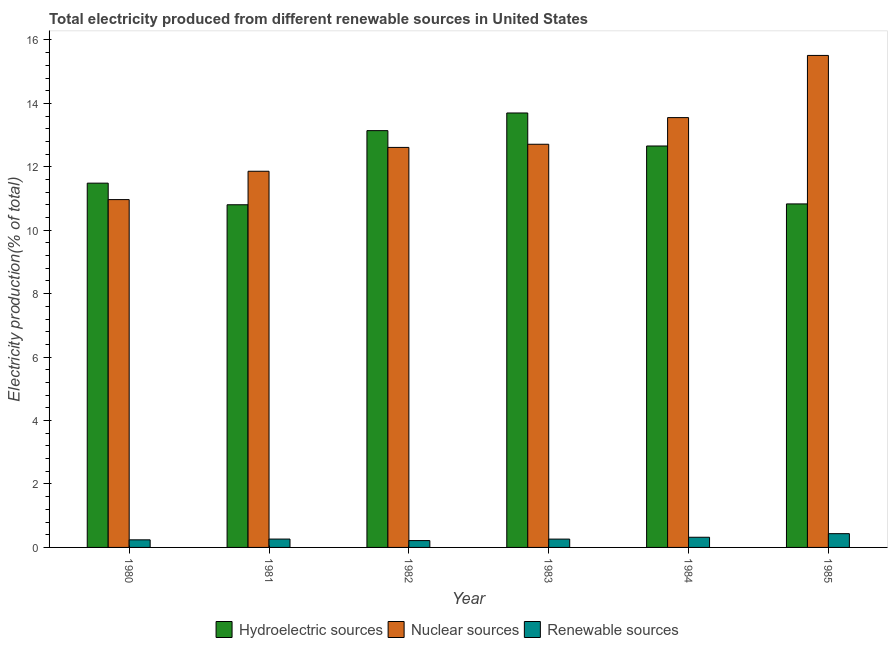How many groups of bars are there?
Ensure brevity in your answer.  6. Are the number of bars on each tick of the X-axis equal?
Your answer should be compact. Yes. How many bars are there on the 5th tick from the left?
Keep it short and to the point. 3. How many bars are there on the 4th tick from the right?
Provide a short and direct response. 3. What is the label of the 1st group of bars from the left?
Keep it short and to the point. 1980. What is the percentage of electricity produced by nuclear sources in 1980?
Make the answer very short. 10.97. Across all years, what is the maximum percentage of electricity produced by hydroelectric sources?
Offer a terse response. 13.7. Across all years, what is the minimum percentage of electricity produced by renewable sources?
Provide a short and direct response. 0.22. In which year was the percentage of electricity produced by hydroelectric sources maximum?
Give a very brief answer. 1983. What is the total percentage of electricity produced by hydroelectric sources in the graph?
Provide a succinct answer. 72.61. What is the difference between the percentage of electricity produced by nuclear sources in 1981 and that in 1985?
Give a very brief answer. -3.65. What is the difference between the percentage of electricity produced by nuclear sources in 1983 and the percentage of electricity produced by renewable sources in 1981?
Your answer should be compact. 0.85. What is the average percentage of electricity produced by nuclear sources per year?
Offer a terse response. 12.87. What is the ratio of the percentage of electricity produced by renewable sources in 1981 to that in 1985?
Keep it short and to the point. 0.61. Is the percentage of electricity produced by nuclear sources in 1980 less than that in 1984?
Your answer should be compact. Yes. What is the difference between the highest and the second highest percentage of electricity produced by hydroelectric sources?
Your response must be concise. 0.56. What is the difference between the highest and the lowest percentage of electricity produced by nuclear sources?
Provide a short and direct response. 4.55. In how many years, is the percentage of electricity produced by hydroelectric sources greater than the average percentage of electricity produced by hydroelectric sources taken over all years?
Ensure brevity in your answer.  3. What does the 1st bar from the left in 1984 represents?
Your answer should be compact. Hydroelectric sources. What does the 2nd bar from the right in 1984 represents?
Give a very brief answer. Nuclear sources. Are all the bars in the graph horizontal?
Give a very brief answer. No. What is the difference between two consecutive major ticks on the Y-axis?
Your response must be concise. 2. Are the values on the major ticks of Y-axis written in scientific E-notation?
Your answer should be compact. No. Does the graph contain any zero values?
Keep it short and to the point. No. What is the title of the graph?
Give a very brief answer. Total electricity produced from different renewable sources in United States. What is the label or title of the Y-axis?
Your answer should be compact. Electricity production(% of total). What is the Electricity production(% of total) of Hydroelectric sources in 1980?
Ensure brevity in your answer.  11.49. What is the Electricity production(% of total) of Nuclear sources in 1980?
Your answer should be compact. 10.97. What is the Electricity production(% of total) of Renewable sources in 1980?
Provide a short and direct response. 0.24. What is the Electricity production(% of total) in Hydroelectric sources in 1981?
Your answer should be compact. 10.8. What is the Electricity production(% of total) of Nuclear sources in 1981?
Your response must be concise. 11.86. What is the Electricity production(% of total) in Renewable sources in 1981?
Provide a succinct answer. 0.26. What is the Electricity production(% of total) of Hydroelectric sources in 1982?
Your response must be concise. 13.14. What is the Electricity production(% of total) in Nuclear sources in 1982?
Make the answer very short. 12.61. What is the Electricity production(% of total) in Renewable sources in 1982?
Your answer should be compact. 0.22. What is the Electricity production(% of total) in Hydroelectric sources in 1983?
Your answer should be very brief. 13.7. What is the Electricity production(% of total) in Nuclear sources in 1983?
Keep it short and to the point. 12.71. What is the Electricity production(% of total) in Renewable sources in 1983?
Your response must be concise. 0.26. What is the Electricity production(% of total) of Hydroelectric sources in 1984?
Give a very brief answer. 12.66. What is the Electricity production(% of total) of Nuclear sources in 1984?
Give a very brief answer. 13.55. What is the Electricity production(% of total) of Renewable sources in 1984?
Offer a terse response. 0.32. What is the Electricity production(% of total) in Hydroelectric sources in 1985?
Ensure brevity in your answer.  10.83. What is the Electricity production(% of total) in Nuclear sources in 1985?
Make the answer very short. 15.51. What is the Electricity production(% of total) of Renewable sources in 1985?
Ensure brevity in your answer.  0.43. Across all years, what is the maximum Electricity production(% of total) in Hydroelectric sources?
Give a very brief answer. 13.7. Across all years, what is the maximum Electricity production(% of total) of Nuclear sources?
Provide a succinct answer. 15.51. Across all years, what is the maximum Electricity production(% of total) of Renewable sources?
Give a very brief answer. 0.43. Across all years, what is the minimum Electricity production(% of total) of Hydroelectric sources?
Your response must be concise. 10.8. Across all years, what is the minimum Electricity production(% of total) of Nuclear sources?
Your answer should be compact. 10.97. Across all years, what is the minimum Electricity production(% of total) of Renewable sources?
Keep it short and to the point. 0.22. What is the total Electricity production(% of total) in Hydroelectric sources in the graph?
Your response must be concise. 72.61. What is the total Electricity production(% of total) in Nuclear sources in the graph?
Your answer should be very brief. 77.21. What is the total Electricity production(% of total) of Renewable sources in the graph?
Your answer should be compact. 1.74. What is the difference between the Electricity production(% of total) in Hydroelectric sources in 1980 and that in 1981?
Give a very brief answer. 0.68. What is the difference between the Electricity production(% of total) in Nuclear sources in 1980 and that in 1981?
Your answer should be compact. -0.89. What is the difference between the Electricity production(% of total) of Renewable sources in 1980 and that in 1981?
Offer a very short reply. -0.02. What is the difference between the Electricity production(% of total) of Hydroelectric sources in 1980 and that in 1982?
Provide a succinct answer. -1.66. What is the difference between the Electricity production(% of total) in Nuclear sources in 1980 and that in 1982?
Keep it short and to the point. -1.65. What is the difference between the Electricity production(% of total) of Renewable sources in 1980 and that in 1982?
Your response must be concise. 0.02. What is the difference between the Electricity production(% of total) in Hydroelectric sources in 1980 and that in 1983?
Your answer should be very brief. -2.21. What is the difference between the Electricity production(% of total) in Nuclear sources in 1980 and that in 1983?
Ensure brevity in your answer.  -1.74. What is the difference between the Electricity production(% of total) in Renewable sources in 1980 and that in 1983?
Provide a short and direct response. -0.02. What is the difference between the Electricity production(% of total) in Hydroelectric sources in 1980 and that in 1984?
Provide a short and direct response. -1.17. What is the difference between the Electricity production(% of total) of Nuclear sources in 1980 and that in 1984?
Keep it short and to the point. -2.59. What is the difference between the Electricity production(% of total) of Renewable sources in 1980 and that in 1984?
Provide a short and direct response. -0.08. What is the difference between the Electricity production(% of total) in Hydroelectric sources in 1980 and that in 1985?
Offer a terse response. 0.65. What is the difference between the Electricity production(% of total) of Nuclear sources in 1980 and that in 1985?
Provide a short and direct response. -4.55. What is the difference between the Electricity production(% of total) of Renewable sources in 1980 and that in 1985?
Ensure brevity in your answer.  -0.19. What is the difference between the Electricity production(% of total) in Hydroelectric sources in 1981 and that in 1982?
Make the answer very short. -2.34. What is the difference between the Electricity production(% of total) in Nuclear sources in 1981 and that in 1982?
Ensure brevity in your answer.  -0.75. What is the difference between the Electricity production(% of total) in Renewable sources in 1981 and that in 1982?
Provide a short and direct response. 0.05. What is the difference between the Electricity production(% of total) of Hydroelectric sources in 1981 and that in 1983?
Your response must be concise. -2.89. What is the difference between the Electricity production(% of total) of Nuclear sources in 1981 and that in 1983?
Your answer should be compact. -0.85. What is the difference between the Electricity production(% of total) of Renewable sources in 1981 and that in 1983?
Offer a very short reply. 0. What is the difference between the Electricity production(% of total) in Hydroelectric sources in 1981 and that in 1984?
Keep it short and to the point. -1.85. What is the difference between the Electricity production(% of total) of Nuclear sources in 1981 and that in 1984?
Keep it short and to the point. -1.69. What is the difference between the Electricity production(% of total) of Renewable sources in 1981 and that in 1984?
Provide a succinct answer. -0.06. What is the difference between the Electricity production(% of total) of Hydroelectric sources in 1981 and that in 1985?
Ensure brevity in your answer.  -0.03. What is the difference between the Electricity production(% of total) in Nuclear sources in 1981 and that in 1985?
Keep it short and to the point. -3.65. What is the difference between the Electricity production(% of total) of Renewable sources in 1981 and that in 1985?
Ensure brevity in your answer.  -0.17. What is the difference between the Electricity production(% of total) in Hydroelectric sources in 1982 and that in 1983?
Your answer should be compact. -0.56. What is the difference between the Electricity production(% of total) in Nuclear sources in 1982 and that in 1983?
Provide a short and direct response. -0.1. What is the difference between the Electricity production(% of total) of Renewable sources in 1982 and that in 1983?
Your response must be concise. -0.05. What is the difference between the Electricity production(% of total) of Hydroelectric sources in 1982 and that in 1984?
Your answer should be compact. 0.48. What is the difference between the Electricity production(% of total) in Nuclear sources in 1982 and that in 1984?
Your answer should be compact. -0.94. What is the difference between the Electricity production(% of total) of Renewable sources in 1982 and that in 1984?
Your answer should be very brief. -0.11. What is the difference between the Electricity production(% of total) of Hydroelectric sources in 1982 and that in 1985?
Provide a short and direct response. 2.31. What is the difference between the Electricity production(% of total) of Renewable sources in 1982 and that in 1985?
Ensure brevity in your answer.  -0.22. What is the difference between the Electricity production(% of total) in Hydroelectric sources in 1983 and that in 1984?
Your answer should be compact. 1.04. What is the difference between the Electricity production(% of total) of Nuclear sources in 1983 and that in 1984?
Offer a very short reply. -0.84. What is the difference between the Electricity production(% of total) in Renewable sources in 1983 and that in 1984?
Provide a short and direct response. -0.06. What is the difference between the Electricity production(% of total) of Hydroelectric sources in 1983 and that in 1985?
Provide a succinct answer. 2.87. What is the difference between the Electricity production(% of total) in Nuclear sources in 1983 and that in 1985?
Provide a short and direct response. -2.8. What is the difference between the Electricity production(% of total) in Renewable sources in 1983 and that in 1985?
Your answer should be compact. -0.17. What is the difference between the Electricity production(% of total) in Hydroelectric sources in 1984 and that in 1985?
Your answer should be compact. 1.83. What is the difference between the Electricity production(% of total) of Nuclear sources in 1984 and that in 1985?
Make the answer very short. -1.96. What is the difference between the Electricity production(% of total) of Renewable sources in 1984 and that in 1985?
Ensure brevity in your answer.  -0.11. What is the difference between the Electricity production(% of total) in Hydroelectric sources in 1980 and the Electricity production(% of total) in Nuclear sources in 1981?
Offer a very short reply. -0.38. What is the difference between the Electricity production(% of total) of Hydroelectric sources in 1980 and the Electricity production(% of total) of Renewable sources in 1981?
Offer a very short reply. 11.22. What is the difference between the Electricity production(% of total) in Nuclear sources in 1980 and the Electricity production(% of total) in Renewable sources in 1981?
Provide a succinct answer. 10.7. What is the difference between the Electricity production(% of total) of Hydroelectric sources in 1980 and the Electricity production(% of total) of Nuclear sources in 1982?
Provide a succinct answer. -1.13. What is the difference between the Electricity production(% of total) of Hydroelectric sources in 1980 and the Electricity production(% of total) of Renewable sources in 1982?
Make the answer very short. 11.27. What is the difference between the Electricity production(% of total) in Nuclear sources in 1980 and the Electricity production(% of total) in Renewable sources in 1982?
Your answer should be compact. 10.75. What is the difference between the Electricity production(% of total) of Hydroelectric sources in 1980 and the Electricity production(% of total) of Nuclear sources in 1983?
Your answer should be very brief. -1.23. What is the difference between the Electricity production(% of total) of Hydroelectric sources in 1980 and the Electricity production(% of total) of Renewable sources in 1983?
Make the answer very short. 11.22. What is the difference between the Electricity production(% of total) in Nuclear sources in 1980 and the Electricity production(% of total) in Renewable sources in 1983?
Make the answer very short. 10.7. What is the difference between the Electricity production(% of total) in Hydroelectric sources in 1980 and the Electricity production(% of total) in Nuclear sources in 1984?
Provide a short and direct response. -2.07. What is the difference between the Electricity production(% of total) in Hydroelectric sources in 1980 and the Electricity production(% of total) in Renewable sources in 1984?
Make the answer very short. 11.16. What is the difference between the Electricity production(% of total) of Nuclear sources in 1980 and the Electricity production(% of total) of Renewable sources in 1984?
Make the answer very short. 10.65. What is the difference between the Electricity production(% of total) of Hydroelectric sources in 1980 and the Electricity production(% of total) of Nuclear sources in 1985?
Offer a very short reply. -4.03. What is the difference between the Electricity production(% of total) in Hydroelectric sources in 1980 and the Electricity production(% of total) in Renewable sources in 1985?
Your response must be concise. 11.05. What is the difference between the Electricity production(% of total) of Nuclear sources in 1980 and the Electricity production(% of total) of Renewable sources in 1985?
Ensure brevity in your answer.  10.53. What is the difference between the Electricity production(% of total) of Hydroelectric sources in 1981 and the Electricity production(% of total) of Nuclear sources in 1982?
Offer a very short reply. -1.81. What is the difference between the Electricity production(% of total) of Hydroelectric sources in 1981 and the Electricity production(% of total) of Renewable sources in 1982?
Ensure brevity in your answer.  10.59. What is the difference between the Electricity production(% of total) in Nuclear sources in 1981 and the Electricity production(% of total) in Renewable sources in 1982?
Make the answer very short. 11.64. What is the difference between the Electricity production(% of total) of Hydroelectric sources in 1981 and the Electricity production(% of total) of Nuclear sources in 1983?
Your response must be concise. -1.91. What is the difference between the Electricity production(% of total) in Hydroelectric sources in 1981 and the Electricity production(% of total) in Renewable sources in 1983?
Keep it short and to the point. 10.54. What is the difference between the Electricity production(% of total) in Nuclear sources in 1981 and the Electricity production(% of total) in Renewable sources in 1983?
Offer a very short reply. 11.6. What is the difference between the Electricity production(% of total) in Hydroelectric sources in 1981 and the Electricity production(% of total) in Nuclear sources in 1984?
Offer a terse response. -2.75. What is the difference between the Electricity production(% of total) in Hydroelectric sources in 1981 and the Electricity production(% of total) in Renewable sources in 1984?
Offer a terse response. 10.48. What is the difference between the Electricity production(% of total) in Nuclear sources in 1981 and the Electricity production(% of total) in Renewable sources in 1984?
Provide a succinct answer. 11.54. What is the difference between the Electricity production(% of total) of Hydroelectric sources in 1981 and the Electricity production(% of total) of Nuclear sources in 1985?
Make the answer very short. -4.71. What is the difference between the Electricity production(% of total) in Hydroelectric sources in 1981 and the Electricity production(% of total) in Renewable sources in 1985?
Provide a short and direct response. 10.37. What is the difference between the Electricity production(% of total) of Nuclear sources in 1981 and the Electricity production(% of total) of Renewable sources in 1985?
Make the answer very short. 11.43. What is the difference between the Electricity production(% of total) of Hydroelectric sources in 1982 and the Electricity production(% of total) of Nuclear sources in 1983?
Give a very brief answer. 0.43. What is the difference between the Electricity production(% of total) of Hydroelectric sources in 1982 and the Electricity production(% of total) of Renewable sources in 1983?
Provide a short and direct response. 12.88. What is the difference between the Electricity production(% of total) of Nuclear sources in 1982 and the Electricity production(% of total) of Renewable sources in 1983?
Give a very brief answer. 12.35. What is the difference between the Electricity production(% of total) in Hydroelectric sources in 1982 and the Electricity production(% of total) in Nuclear sources in 1984?
Offer a very short reply. -0.41. What is the difference between the Electricity production(% of total) of Hydroelectric sources in 1982 and the Electricity production(% of total) of Renewable sources in 1984?
Provide a succinct answer. 12.82. What is the difference between the Electricity production(% of total) of Nuclear sources in 1982 and the Electricity production(% of total) of Renewable sources in 1984?
Give a very brief answer. 12.29. What is the difference between the Electricity production(% of total) of Hydroelectric sources in 1982 and the Electricity production(% of total) of Nuclear sources in 1985?
Your answer should be very brief. -2.37. What is the difference between the Electricity production(% of total) in Hydroelectric sources in 1982 and the Electricity production(% of total) in Renewable sources in 1985?
Provide a short and direct response. 12.71. What is the difference between the Electricity production(% of total) of Nuclear sources in 1982 and the Electricity production(% of total) of Renewable sources in 1985?
Your answer should be very brief. 12.18. What is the difference between the Electricity production(% of total) in Hydroelectric sources in 1983 and the Electricity production(% of total) in Nuclear sources in 1984?
Offer a terse response. 0.15. What is the difference between the Electricity production(% of total) in Hydroelectric sources in 1983 and the Electricity production(% of total) in Renewable sources in 1984?
Your answer should be compact. 13.38. What is the difference between the Electricity production(% of total) of Nuclear sources in 1983 and the Electricity production(% of total) of Renewable sources in 1984?
Your response must be concise. 12.39. What is the difference between the Electricity production(% of total) in Hydroelectric sources in 1983 and the Electricity production(% of total) in Nuclear sources in 1985?
Your response must be concise. -1.81. What is the difference between the Electricity production(% of total) of Hydroelectric sources in 1983 and the Electricity production(% of total) of Renewable sources in 1985?
Offer a very short reply. 13.26. What is the difference between the Electricity production(% of total) in Nuclear sources in 1983 and the Electricity production(% of total) in Renewable sources in 1985?
Give a very brief answer. 12.28. What is the difference between the Electricity production(% of total) of Hydroelectric sources in 1984 and the Electricity production(% of total) of Nuclear sources in 1985?
Provide a short and direct response. -2.86. What is the difference between the Electricity production(% of total) in Hydroelectric sources in 1984 and the Electricity production(% of total) in Renewable sources in 1985?
Make the answer very short. 12.22. What is the difference between the Electricity production(% of total) of Nuclear sources in 1984 and the Electricity production(% of total) of Renewable sources in 1985?
Your answer should be very brief. 13.12. What is the average Electricity production(% of total) in Hydroelectric sources per year?
Your answer should be compact. 12.1. What is the average Electricity production(% of total) in Nuclear sources per year?
Make the answer very short. 12.87. What is the average Electricity production(% of total) of Renewable sources per year?
Provide a short and direct response. 0.29. In the year 1980, what is the difference between the Electricity production(% of total) of Hydroelectric sources and Electricity production(% of total) of Nuclear sources?
Give a very brief answer. 0.52. In the year 1980, what is the difference between the Electricity production(% of total) of Hydroelectric sources and Electricity production(% of total) of Renewable sources?
Offer a terse response. 11.25. In the year 1980, what is the difference between the Electricity production(% of total) in Nuclear sources and Electricity production(% of total) in Renewable sources?
Your answer should be compact. 10.73. In the year 1981, what is the difference between the Electricity production(% of total) of Hydroelectric sources and Electricity production(% of total) of Nuclear sources?
Provide a succinct answer. -1.06. In the year 1981, what is the difference between the Electricity production(% of total) in Hydroelectric sources and Electricity production(% of total) in Renewable sources?
Ensure brevity in your answer.  10.54. In the year 1981, what is the difference between the Electricity production(% of total) in Nuclear sources and Electricity production(% of total) in Renewable sources?
Your answer should be very brief. 11.6. In the year 1982, what is the difference between the Electricity production(% of total) in Hydroelectric sources and Electricity production(% of total) in Nuclear sources?
Give a very brief answer. 0.53. In the year 1982, what is the difference between the Electricity production(% of total) of Hydroelectric sources and Electricity production(% of total) of Renewable sources?
Make the answer very short. 12.93. In the year 1982, what is the difference between the Electricity production(% of total) of Nuclear sources and Electricity production(% of total) of Renewable sources?
Your answer should be very brief. 12.4. In the year 1983, what is the difference between the Electricity production(% of total) in Hydroelectric sources and Electricity production(% of total) in Nuclear sources?
Make the answer very short. 0.99. In the year 1983, what is the difference between the Electricity production(% of total) of Hydroelectric sources and Electricity production(% of total) of Renewable sources?
Ensure brevity in your answer.  13.43. In the year 1983, what is the difference between the Electricity production(% of total) of Nuclear sources and Electricity production(% of total) of Renewable sources?
Offer a terse response. 12.45. In the year 1984, what is the difference between the Electricity production(% of total) of Hydroelectric sources and Electricity production(% of total) of Nuclear sources?
Offer a very short reply. -0.89. In the year 1984, what is the difference between the Electricity production(% of total) of Hydroelectric sources and Electricity production(% of total) of Renewable sources?
Offer a terse response. 12.34. In the year 1984, what is the difference between the Electricity production(% of total) in Nuclear sources and Electricity production(% of total) in Renewable sources?
Keep it short and to the point. 13.23. In the year 1985, what is the difference between the Electricity production(% of total) of Hydroelectric sources and Electricity production(% of total) of Nuclear sources?
Ensure brevity in your answer.  -4.68. In the year 1985, what is the difference between the Electricity production(% of total) in Hydroelectric sources and Electricity production(% of total) in Renewable sources?
Make the answer very short. 10.4. In the year 1985, what is the difference between the Electricity production(% of total) of Nuclear sources and Electricity production(% of total) of Renewable sources?
Your response must be concise. 15.08. What is the ratio of the Electricity production(% of total) in Hydroelectric sources in 1980 to that in 1981?
Offer a terse response. 1.06. What is the ratio of the Electricity production(% of total) in Nuclear sources in 1980 to that in 1981?
Provide a short and direct response. 0.92. What is the ratio of the Electricity production(% of total) in Renewable sources in 1980 to that in 1981?
Give a very brief answer. 0.91. What is the ratio of the Electricity production(% of total) in Hydroelectric sources in 1980 to that in 1982?
Offer a very short reply. 0.87. What is the ratio of the Electricity production(% of total) in Nuclear sources in 1980 to that in 1982?
Ensure brevity in your answer.  0.87. What is the ratio of the Electricity production(% of total) in Renewable sources in 1980 to that in 1982?
Your response must be concise. 1.11. What is the ratio of the Electricity production(% of total) of Hydroelectric sources in 1980 to that in 1983?
Your answer should be compact. 0.84. What is the ratio of the Electricity production(% of total) in Nuclear sources in 1980 to that in 1983?
Make the answer very short. 0.86. What is the ratio of the Electricity production(% of total) of Renewable sources in 1980 to that in 1983?
Keep it short and to the point. 0.91. What is the ratio of the Electricity production(% of total) of Hydroelectric sources in 1980 to that in 1984?
Make the answer very short. 0.91. What is the ratio of the Electricity production(% of total) of Nuclear sources in 1980 to that in 1984?
Offer a very short reply. 0.81. What is the ratio of the Electricity production(% of total) in Renewable sources in 1980 to that in 1984?
Make the answer very short. 0.75. What is the ratio of the Electricity production(% of total) in Hydroelectric sources in 1980 to that in 1985?
Offer a terse response. 1.06. What is the ratio of the Electricity production(% of total) of Nuclear sources in 1980 to that in 1985?
Make the answer very short. 0.71. What is the ratio of the Electricity production(% of total) in Renewable sources in 1980 to that in 1985?
Ensure brevity in your answer.  0.55. What is the ratio of the Electricity production(% of total) in Hydroelectric sources in 1981 to that in 1982?
Ensure brevity in your answer.  0.82. What is the ratio of the Electricity production(% of total) in Nuclear sources in 1981 to that in 1982?
Offer a terse response. 0.94. What is the ratio of the Electricity production(% of total) of Renewable sources in 1981 to that in 1982?
Give a very brief answer. 1.22. What is the ratio of the Electricity production(% of total) in Hydroelectric sources in 1981 to that in 1983?
Ensure brevity in your answer.  0.79. What is the ratio of the Electricity production(% of total) in Nuclear sources in 1981 to that in 1983?
Keep it short and to the point. 0.93. What is the ratio of the Electricity production(% of total) of Hydroelectric sources in 1981 to that in 1984?
Offer a terse response. 0.85. What is the ratio of the Electricity production(% of total) in Nuclear sources in 1981 to that in 1984?
Give a very brief answer. 0.88. What is the ratio of the Electricity production(% of total) in Renewable sources in 1981 to that in 1984?
Keep it short and to the point. 0.82. What is the ratio of the Electricity production(% of total) in Hydroelectric sources in 1981 to that in 1985?
Your answer should be compact. 1. What is the ratio of the Electricity production(% of total) of Nuclear sources in 1981 to that in 1985?
Offer a very short reply. 0.76. What is the ratio of the Electricity production(% of total) of Renewable sources in 1981 to that in 1985?
Ensure brevity in your answer.  0.61. What is the ratio of the Electricity production(% of total) of Hydroelectric sources in 1982 to that in 1983?
Your answer should be compact. 0.96. What is the ratio of the Electricity production(% of total) of Renewable sources in 1982 to that in 1983?
Provide a short and direct response. 0.82. What is the ratio of the Electricity production(% of total) in Hydroelectric sources in 1982 to that in 1984?
Your answer should be compact. 1.04. What is the ratio of the Electricity production(% of total) in Nuclear sources in 1982 to that in 1984?
Your answer should be compact. 0.93. What is the ratio of the Electricity production(% of total) of Renewable sources in 1982 to that in 1984?
Provide a succinct answer. 0.67. What is the ratio of the Electricity production(% of total) in Hydroelectric sources in 1982 to that in 1985?
Ensure brevity in your answer.  1.21. What is the ratio of the Electricity production(% of total) in Nuclear sources in 1982 to that in 1985?
Provide a short and direct response. 0.81. What is the ratio of the Electricity production(% of total) in Renewable sources in 1982 to that in 1985?
Give a very brief answer. 0.5. What is the ratio of the Electricity production(% of total) of Hydroelectric sources in 1983 to that in 1984?
Ensure brevity in your answer.  1.08. What is the ratio of the Electricity production(% of total) of Nuclear sources in 1983 to that in 1984?
Offer a terse response. 0.94. What is the ratio of the Electricity production(% of total) in Renewable sources in 1983 to that in 1984?
Provide a succinct answer. 0.82. What is the ratio of the Electricity production(% of total) in Hydroelectric sources in 1983 to that in 1985?
Make the answer very short. 1.26. What is the ratio of the Electricity production(% of total) in Nuclear sources in 1983 to that in 1985?
Your response must be concise. 0.82. What is the ratio of the Electricity production(% of total) in Renewable sources in 1983 to that in 1985?
Your answer should be very brief. 0.6. What is the ratio of the Electricity production(% of total) of Hydroelectric sources in 1984 to that in 1985?
Your answer should be compact. 1.17. What is the ratio of the Electricity production(% of total) in Nuclear sources in 1984 to that in 1985?
Provide a short and direct response. 0.87. What is the ratio of the Electricity production(% of total) of Renewable sources in 1984 to that in 1985?
Your response must be concise. 0.74. What is the difference between the highest and the second highest Electricity production(% of total) in Hydroelectric sources?
Give a very brief answer. 0.56. What is the difference between the highest and the second highest Electricity production(% of total) of Nuclear sources?
Make the answer very short. 1.96. What is the difference between the highest and the second highest Electricity production(% of total) of Renewable sources?
Your answer should be compact. 0.11. What is the difference between the highest and the lowest Electricity production(% of total) of Hydroelectric sources?
Your answer should be compact. 2.89. What is the difference between the highest and the lowest Electricity production(% of total) of Nuclear sources?
Offer a terse response. 4.55. What is the difference between the highest and the lowest Electricity production(% of total) in Renewable sources?
Make the answer very short. 0.22. 